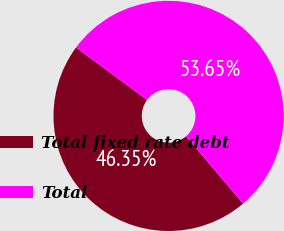Convert chart. <chart><loc_0><loc_0><loc_500><loc_500><pie_chart><fcel>Total fixed rate debt<fcel>Total<nl><fcel>46.35%<fcel>53.65%<nl></chart> 